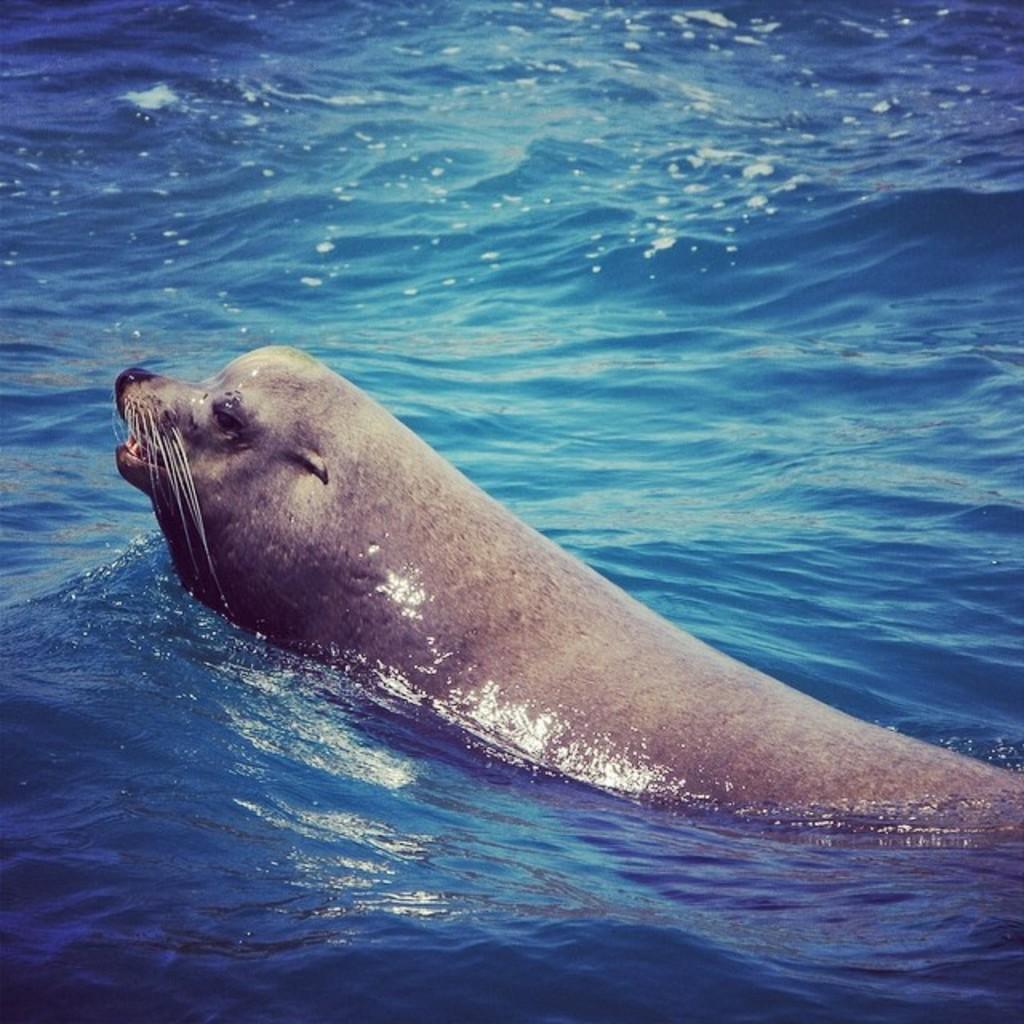In one or two sentences, can you explain what this image depicts? As we can see in the image there is water and an animal. 